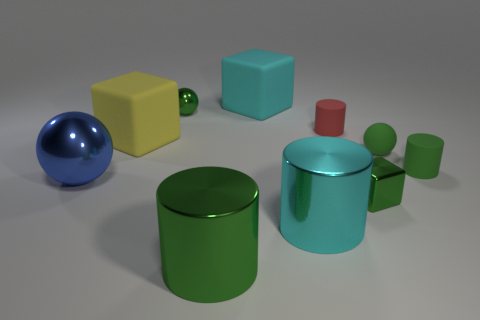Please describe the texture of the objects in the image. Certainly! The objects in the image appear to have a smooth, matte finish, with the exception of the large sphere which has a shiny, reflective surface. Differences in texture are subtly indicated by the way light interacts with the surfaces of the objects. 